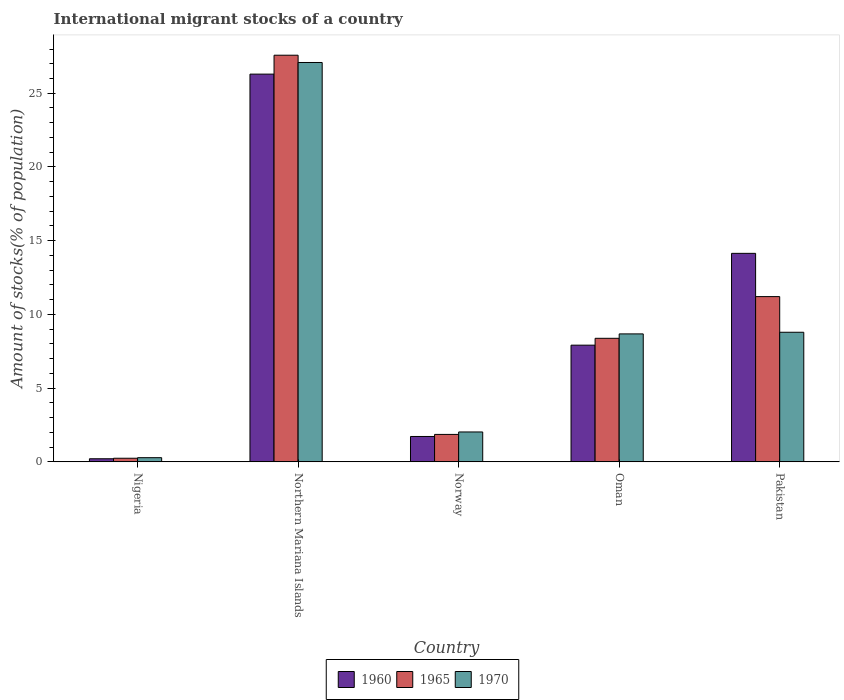How many groups of bars are there?
Provide a short and direct response. 5. Are the number of bars per tick equal to the number of legend labels?
Your response must be concise. Yes. How many bars are there on the 1st tick from the left?
Offer a very short reply. 3. What is the label of the 2nd group of bars from the left?
Your answer should be compact. Northern Mariana Islands. In how many cases, is the number of bars for a given country not equal to the number of legend labels?
Your answer should be compact. 0. What is the amount of stocks in in 1960 in Oman?
Offer a terse response. 7.91. Across all countries, what is the maximum amount of stocks in in 1965?
Your answer should be very brief. 27.58. Across all countries, what is the minimum amount of stocks in in 1960?
Make the answer very short. 0.21. In which country was the amount of stocks in in 1960 maximum?
Your answer should be very brief. Northern Mariana Islands. In which country was the amount of stocks in in 1970 minimum?
Offer a terse response. Nigeria. What is the total amount of stocks in in 1970 in the graph?
Offer a very short reply. 46.86. What is the difference between the amount of stocks in in 1970 in Nigeria and that in Northern Mariana Islands?
Provide a succinct answer. -26.8. What is the difference between the amount of stocks in in 1970 in Oman and the amount of stocks in in 1965 in Pakistan?
Provide a succinct answer. -2.53. What is the average amount of stocks in in 1960 per country?
Your answer should be compact. 10.06. What is the difference between the amount of stocks in of/in 1960 and amount of stocks in of/in 1970 in Pakistan?
Give a very brief answer. 5.35. What is the ratio of the amount of stocks in in 1965 in Nigeria to that in Northern Mariana Islands?
Your response must be concise. 0.01. Is the amount of stocks in in 1965 in Northern Mariana Islands less than that in Norway?
Provide a succinct answer. No. Is the difference between the amount of stocks in in 1960 in Nigeria and Northern Mariana Islands greater than the difference between the amount of stocks in in 1970 in Nigeria and Northern Mariana Islands?
Provide a succinct answer. Yes. What is the difference between the highest and the second highest amount of stocks in in 1965?
Your answer should be very brief. 2.83. What is the difference between the highest and the lowest amount of stocks in in 1970?
Provide a short and direct response. 26.8. In how many countries, is the amount of stocks in in 1970 greater than the average amount of stocks in in 1970 taken over all countries?
Provide a succinct answer. 1. What does the 1st bar from the left in Nigeria represents?
Your response must be concise. 1960. How many bars are there?
Provide a short and direct response. 15. How many countries are there in the graph?
Give a very brief answer. 5. Are the values on the major ticks of Y-axis written in scientific E-notation?
Provide a short and direct response. No. Does the graph contain any zero values?
Keep it short and to the point. No. Does the graph contain grids?
Your answer should be very brief. No. Where does the legend appear in the graph?
Provide a short and direct response. Bottom center. What is the title of the graph?
Your answer should be compact. International migrant stocks of a country. Does "1974" appear as one of the legend labels in the graph?
Make the answer very short. No. What is the label or title of the Y-axis?
Ensure brevity in your answer.  Amount of stocks(% of population). What is the Amount of stocks(% of population) in 1960 in Nigeria?
Your answer should be compact. 0.21. What is the Amount of stocks(% of population) in 1965 in Nigeria?
Your answer should be very brief. 0.24. What is the Amount of stocks(% of population) of 1970 in Nigeria?
Your answer should be very brief. 0.28. What is the Amount of stocks(% of population) in 1960 in Northern Mariana Islands?
Your answer should be compact. 26.3. What is the Amount of stocks(% of population) in 1965 in Northern Mariana Islands?
Give a very brief answer. 27.58. What is the Amount of stocks(% of population) of 1970 in Northern Mariana Islands?
Ensure brevity in your answer.  27.08. What is the Amount of stocks(% of population) of 1960 in Norway?
Make the answer very short. 1.72. What is the Amount of stocks(% of population) in 1965 in Norway?
Make the answer very short. 1.86. What is the Amount of stocks(% of population) in 1970 in Norway?
Make the answer very short. 2.03. What is the Amount of stocks(% of population) of 1960 in Oman?
Offer a terse response. 7.91. What is the Amount of stocks(% of population) of 1965 in Oman?
Keep it short and to the point. 8.38. What is the Amount of stocks(% of population) of 1970 in Oman?
Keep it short and to the point. 8.68. What is the Amount of stocks(% of population) in 1960 in Pakistan?
Your answer should be very brief. 14.14. What is the Amount of stocks(% of population) in 1965 in Pakistan?
Ensure brevity in your answer.  11.21. What is the Amount of stocks(% of population) in 1970 in Pakistan?
Keep it short and to the point. 8.79. Across all countries, what is the maximum Amount of stocks(% of population) in 1960?
Keep it short and to the point. 26.3. Across all countries, what is the maximum Amount of stocks(% of population) of 1965?
Ensure brevity in your answer.  27.58. Across all countries, what is the maximum Amount of stocks(% of population) of 1970?
Provide a succinct answer. 27.08. Across all countries, what is the minimum Amount of stocks(% of population) of 1960?
Make the answer very short. 0.21. Across all countries, what is the minimum Amount of stocks(% of population) of 1965?
Give a very brief answer. 0.24. Across all countries, what is the minimum Amount of stocks(% of population) in 1970?
Your response must be concise. 0.28. What is the total Amount of stocks(% of population) of 1960 in the graph?
Your answer should be compact. 50.28. What is the total Amount of stocks(% of population) of 1965 in the graph?
Your answer should be very brief. 49.27. What is the total Amount of stocks(% of population) in 1970 in the graph?
Your answer should be very brief. 46.86. What is the difference between the Amount of stocks(% of population) of 1960 in Nigeria and that in Northern Mariana Islands?
Give a very brief answer. -26.09. What is the difference between the Amount of stocks(% of population) in 1965 in Nigeria and that in Northern Mariana Islands?
Give a very brief answer. -27.34. What is the difference between the Amount of stocks(% of population) in 1970 in Nigeria and that in Northern Mariana Islands?
Your answer should be very brief. -26.8. What is the difference between the Amount of stocks(% of population) of 1960 in Nigeria and that in Norway?
Your answer should be compact. -1.51. What is the difference between the Amount of stocks(% of population) of 1965 in Nigeria and that in Norway?
Ensure brevity in your answer.  -1.62. What is the difference between the Amount of stocks(% of population) in 1970 in Nigeria and that in Norway?
Your response must be concise. -1.74. What is the difference between the Amount of stocks(% of population) in 1960 in Nigeria and that in Oman?
Make the answer very short. -7.7. What is the difference between the Amount of stocks(% of population) of 1965 in Nigeria and that in Oman?
Your response must be concise. -8.14. What is the difference between the Amount of stocks(% of population) in 1970 in Nigeria and that in Oman?
Provide a short and direct response. -8.4. What is the difference between the Amount of stocks(% of population) of 1960 in Nigeria and that in Pakistan?
Offer a terse response. -13.93. What is the difference between the Amount of stocks(% of population) in 1965 in Nigeria and that in Pakistan?
Offer a very short reply. -10.96. What is the difference between the Amount of stocks(% of population) in 1970 in Nigeria and that in Pakistan?
Provide a short and direct response. -8.51. What is the difference between the Amount of stocks(% of population) of 1960 in Northern Mariana Islands and that in Norway?
Provide a short and direct response. 24.58. What is the difference between the Amount of stocks(% of population) in 1965 in Northern Mariana Islands and that in Norway?
Keep it short and to the point. 25.72. What is the difference between the Amount of stocks(% of population) of 1970 in Northern Mariana Islands and that in Norway?
Make the answer very short. 25.06. What is the difference between the Amount of stocks(% of population) of 1960 in Northern Mariana Islands and that in Oman?
Offer a very short reply. 18.38. What is the difference between the Amount of stocks(% of population) of 1965 in Northern Mariana Islands and that in Oman?
Ensure brevity in your answer.  19.2. What is the difference between the Amount of stocks(% of population) in 1970 in Northern Mariana Islands and that in Oman?
Make the answer very short. 18.41. What is the difference between the Amount of stocks(% of population) of 1960 in Northern Mariana Islands and that in Pakistan?
Give a very brief answer. 12.16. What is the difference between the Amount of stocks(% of population) in 1965 in Northern Mariana Islands and that in Pakistan?
Your response must be concise. 16.37. What is the difference between the Amount of stocks(% of population) of 1970 in Northern Mariana Islands and that in Pakistan?
Offer a very short reply. 18.3. What is the difference between the Amount of stocks(% of population) in 1960 in Norway and that in Oman?
Your answer should be very brief. -6.19. What is the difference between the Amount of stocks(% of population) in 1965 in Norway and that in Oman?
Provide a succinct answer. -6.52. What is the difference between the Amount of stocks(% of population) in 1970 in Norway and that in Oman?
Offer a very short reply. -6.65. What is the difference between the Amount of stocks(% of population) in 1960 in Norway and that in Pakistan?
Offer a terse response. -12.42. What is the difference between the Amount of stocks(% of population) of 1965 in Norway and that in Pakistan?
Your answer should be compact. -9.35. What is the difference between the Amount of stocks(% of population) of 1970 in Norway and that in Pakistan?
Offer a terse response. -6.76. What is the difference between the Amount of stocks(% of population) in 1960 in Oman and that in Pakistan?
Offer a very short reply. -6.23. What is the difference between the Amount of stocks(% of population) in 1965 in Oman and that in Pakistan?
Offer a very short reply. -2.83. What is the difference between the Amount of stocks(% of population) in 1970 in Oman and that in Pakistan?
Provide a succinct answer. -0.11. What is the difference between the Amount of stocks(% of population) of 1960 in Nigeria and the Amount of stocks(% of population) of 1965 in Northern Mariana Islands?
Offer a very short reply. -27.37. What is the difference between the Amount of stocks(% of population) of 1960 in Nigeria and the Amount of stocks(% of population) of 1970 in Northern Mariana Islands?
Keep it short and to the point. -26.88. What is the difference between the Amount of stocks(% of population) of 1965 in Nigeria and the Amount of stocks(% of population) of 1970 in Northern Mariana Islands?
Keep it short and to the point. -26.84. What is the difference between the Amount of stocks(% of population) in 1960 in Nigeria and the Amount of stocks(% of population) in 1965 in Norway?
Offer a very short reply. -1.65. What is the difference between the Amount of stocks(% of population) of 1960 in Nigeria and the Amount of stocks(% of population) of 1970 in Norway?
Give a very brief answer. -1.82. What is the difference between the Amount of stocks(% of population) of 1965 in Nigeria and the Amount of stocks(% of population) of 1970 in Norway?
Your answer should be compact. -1.78. What is the difference between the Amount of stocks(% of population) of 1960 in Nigeria and the Amount of stocks(% of population) of 1965 in Oman?
Provide a short and direct response. -8.17. What is the difference between the Amount of stocks(% of population) of 1960 in Nigeria and the Amount of stocks(% of population) of 1970 in Oman?
Ensure brevity in your answer.  -8.47. What is the difference between the Amount of stocks(% of population) of 1965 in Nigeria and the Amount of stocks(% of population) of 1970 in Oman?
Your answer should be compact. -8.43. What is the difference between the Amount of stocks(% of population) in 1960 in Nigeria and the Amount of stocks(% of population) in 1965 in Pakistan?
Provide a short and direct response. -11. What is the difference between the Amount of stocks(% of population) of 1960 in Nigeria and the Amount of stocks(% of population) of 1970 in Pakistan?
Give a very brief answer. -8.58. What is the difference between the Amount of stocks(% of population) of 1965 in Nigeria and the Amount of stocks(% of population) of 1970 in Pakistan?
Ensure brevity in your answer.  -8.55. What is the difference between the Amount of stocks(% of population) in 1960 in Northern Mariana Islands and the Amount of stocks(% of population) in 1965 in Norway?
Keep it short and to the point. 24.44. What is the difference between the Amount of stocks(% of population) of 1960 in Northern Mariana Islands and the Amount of stocks(% of population) of 1970 in Norway?
Give a very brief answer. 24.27. What is the difference between the Amount of stocks(% of population) in 1965 in Northern Mariana Islands and the Amount of stocks(% of population) in 1970 in Norway?
Keep it short and to the point. 25.55. What is the difference between the Amount of stocks(% of population) of 1960 in Northern Mariana Islands and the Amount of stocks(% of population) of 1965 in Oman?
Offer a very short reply. 17.92. What is the difference between the Amount of stocks(% of population) of 1960 in Northern Mariana Islands and the Amount of stocks(% of population) of 1970 in Oman?
Make the answer very short. 17.62. What is the difference between the Amount of stocks(% of population) in 1965 in Northern Mariana Islands and the Amount of stocks(% of population) in 1970 in Oman?
Your answer should be compact. 18.9. What is the difference between the Amount of stocks(% of population) of 1960 in Northern Mariana Islands and the Amount of stocks(% of population) of 1965 in Pakistan?
Keep it short and to the point. 15.09. What is the difference between the Amount of stocks(% of population) in 1960 in Northern Mariana Islands and the Amount of stocks(% of population) in 1970 in Pakistan?
Offer a very short reply. 17.51. What is the difference between the Amount of stocks(% of population) of 1965 in Northern Mariana Islands and the Amount of stocks(% of population) of 1970 in Pakistan?
Your answer should be very brief. 18.79. What is the difference between the Amount of stocks(% of population) in 1960 in Norway and the Amount of stocks(% of population) in 1965 in Oman?
Offer a terse response. -6.66. What is the difference between the Amount of stocks(% of population) in 1960 in Norway and the Amount of stocks(% of population) in 1970 in Oman?
Give a very brief answer. -6.96. What is the difference between the Amount of stocks(% of population) of 1965 in Norway and the Amount of stocks(% of population) of 1970 in Oman?
Your response must be concise. -6.82. What is the difference between the Amount of stocks(% of population) of 1960 in Norway and the Amount of stocks(% of population) of 1965 in Pakistan?
Make the answer very short. -9.49. What is the difference between the Amount of stocks(% of population) of 1960 in Norway and the Amount of stocks(% of population) of 1970 in Pakistan?
Offer a very short reply. -7.07. What is the difference between the Amount of stocks(% of population) in 1965 in Norway and the Amount of stocks(% of population) in 1970 in Pakistan?
Keep it short and to the point. -6.93. What is the difference between the Amount of stocks(% of population) of 1960 in Oman and the Amount of stocks(% of population) of 1965 in Pakistan?
Offer a terse response. -3.29. What is the difference between the Amount of stocks(% of population) in 1960 in Oman and the Amount of stocks(% of population) in 1970 in Pakistan?
Your response must be concise. -0.88. What is the difference between the Amount of stocks(% of population) of 1965 in Oman and the Amount of stocks(% of population) of 1970 in Pakistan?
Your answer should be very brief. -0.41. What is the average Amount of stocks(% of population) in 1960 per country?
Make the answer very short. 10.06. What is the average Amount of stocks(% of population) of 1965 per country?
Provide a succinct answer. 9.85. What is the average Amount of stocks(% of population) of 1970 per country?
Offer a very short reply. 9.37. What is the difference between the Amount of stocks(% of population) in 1960 and Amount of stocks(% of population) in 1965 in Nigeria?
Provide a succinct answer. -0.03. What is the difference between the Amount of stocks(% of population) in 1960 and Amount of stocks(% of population) in 1970 in Nigeria?
Your response must be concise. -0.07. What is the difference between the Amount of stocks(% of population) in 1965 and Amount of stocks(% of population) in 1970 in Nigeria?
Your answer should be very brief. -0.04. What is the difference between the Amount of stocks(% of population) of 1960 and Amount of stocks(% of population) of 1965 in Northern Mariana Islands?
Offer a terse response. -1.28. What is the difference between the Amount of stocks(% of population) in 1960 and Amount of stocks(% of population) in 1970 in Northern Mariana Islands?
Give a very brief answer. -0.79. What is the difference between the Amount of stocks(% of population) in 1965 and Amount of stocks(% of population) in 1970 in Northern Mariana Islands?
Offer a very short reply. 0.49. What is the difference between the Amount of stocks(% of population) of 1960 and Amount of stocks(% of population) of 1965 in Norway?
Offer a very short reply. -0.14. What is the difference between the Amount of stocks(% of population) of 1960 and Amount of stocks(% of population) of 1970 in Norway?
Offer a very short reply. -0.31. What is the difference between the Amount of stocks(% of population) of 1965 and Amount of stocks(% of population) of 1970 in Norway?
Provide a succinct answer. -0.17. What is the difference between the Amount of stocks(% of population) of 1960 and Amount of stocks(% of population) of 1965 in Oman?
Provide a succinct answer. -0.47. What is the difference between the Amount of stocks(% of population) in 1960 and Amount of stocks(% of population) in 1970 in Oman?
Make the answer very short. -0.76. What is the difference between the Amount of stocks(% of population) of 1965 and Amount of stocks(% of population) of 1970 in Oman?
Make the answer very short. -0.3. What is the difference between the Amount of stocks(% of population) in 1960 and Amount of stocks(% of population) in 1965 in Pakistan?
Your response must be concise. 2.93. What is the difference between the Amount of stocks(% of population) of 1960 and Amount of stocks(% of population) of 1970 in Pakistan?
Provide a short and direct response. 5.35. What is the difference between the Amount of stocks(% of population) of 1965 and Amount of stocks(% of population) of 1970 in Pakistan?
Offer a very short reply. 2.42. What is the ratio of the Amount of stocks(% of population) in 1960 in Nigeria to that in Northern Mariana Islands?
Provide a succinct answer. 0.01. What is the ratio of the Amount of stocks(% of population) of 1965 in Nigeria to that in Northern Mariana Islands?
Offer a very short reply. 0.01. What is the ratio of the Amount of stocks(% of population) of 1970 in Nigeria to that in Northern Mariana Islands?
Offer a terse response. 0.01. What is the ratio of the Amount of stocks(% of population) of 1960 in Nigeria to that in Norway?
Keep it short and to the point. 0.12. What is the ratio of the Amount of stocks(% of population) in 1965 in Nigeria to that in Norway?
Your answer should be very brief. 0.13. What is the ratio of the Amount of stocks(% of population) of 1970 in Nigeria to that in Norway?
Offer a very short reply. 0.14. What is the ratio of the Amount of stocks(% of population) in 1960 in Nigeria to that in Oman?
Your answer should be very brief. 0.03. What is the ratio of the Amount of stocks(% of population) of 1965 in Nigeria to that in Oman?
Keep it short and to the point. 0.03. What is the ratio of the Amount of stocks(% of population) in 1970 in Nigeria to that in Oman?
Make the answer very short. 0.03. What is the ratio of the Amount of stocks(% of population) of 1960 in Nigeria to that in Pakistan?
Offer a terse response. 0.01. What is the ratio of the Amount of stocks(% of population) in 1965 in Nigeria to that in Pakistan?
Give a very brief answer. 0.02. What is the ratio of the Amount of stocks(% of population) of 1970 in Nigeria to that in Pakistan?
Keep it short and to the point. 0.03. What is the ratio of the Amount of stocks(% of population) of 1960 in Northern Mariana Islands to that in Norway?
Make the answer very short. 15.29. What is the ratio of the Amount of stocks(% of population) of 1965 in Northern Mariana Islands to that in Norway?
Keep it short and to the point. 14.84. What is the ratio of the Amount of stocks(% of population) in 1970 in Northern Mariana Islands to that in Norway?
Your answer should be compact. 13.37. What is the ratio of the Amount of stocks(% of population) in 1960 in Northern Mariana Islands to that in Oman?
Offer a terse response. 3.32. What is the ratio of the Amount of stocks(% of population) in 1965 in Northern Mariana Islands to that in Oman?
Provide a short and direct response. 3.29. What is the ratio of the Amount of stocks(% of population) in 1970 in Northern Mariana Islands to that in Oman?
Your response must be concise. 3.12. What is the ratio of the Amount of stocks(% of population) of 1960 in Northern Mariana Islands to that in Pakistan?
Keep it short and to the point. 1.86. What is the ratio of the Amount of stocks(% of population) of 1965 in Northern Mariana Islands to that in Pakistan?
Your answer should be compact. 2.46. What is the ratio of the Amount of stocks(% of population) of 1970 in Northern Mariana Islands to that in Pakistan?
Ensure brevity in your answer.  3.08. What is the ratio of the Amount of stocks(% of population) in 1960 in Norway to that in Oman?
Your response must be concise. 0.22. What is the ratio of the Amount of stocks(% of population) of 1965 in Norway to that in Oman?
Ensure brevity in your answer.  0.22. What is the ratio of the Amount of stocks(% of population) of 1970 in Norway to that in Oman?
Your response must be concise. 0.23. What is the ratio of the Amount of stocks(% of population) in 1960 in Norway to that in Pakistan?
Ensure brevity in your answer.  0.12. What is the ratio of the Amount of stocks(% of population) in 1965 in Norway to that in Pakistan?
Your response must be concise. 0.17. What is the ratio of the Amount of stocks(% of population) of 1970 in Norway to that in Pakistan?
Offer a very short reply. 0.23. What is the ratio of the Amount of stocks(% of population) in 1960 in Oman to that in Pakistan?
Your response must be concise. 0.56. What is the ratio of the Amount of stocks(% of population) of 1965 in Oman to that in Pakistan?
Offer a very short reply. 0.75. What is the ratio of the Amount of stocks(% of population) in 1970 in Oman to that in Pakistan?
Give a very brief answer. 0.99. What is the difference between the highest and the second highest Amount of stocks(% of population) in 1960?
Make the answer very short. 12.16. What is the difference between the highest and the second highest Amount of stocks(% of population) of 1965?
Offer a very short reply. 16.37. What is the difference between the highest and the second highest Amount of stocks(% of population) in 1970?
Your response must be concise. 18.3. What is the difference between the highest and the lowest Amount of stocks(% of population) of 1960?
Provide a succinct answer. 26.09. What is the difference between the highest and the lowest Amount of stocks(% of population) of 1965?
Your answer should be compact. 27.34. What is the difference between the highest and the lowest Amount of stocks(% of population) in 1970?
Offer a terse response. 26.8. 